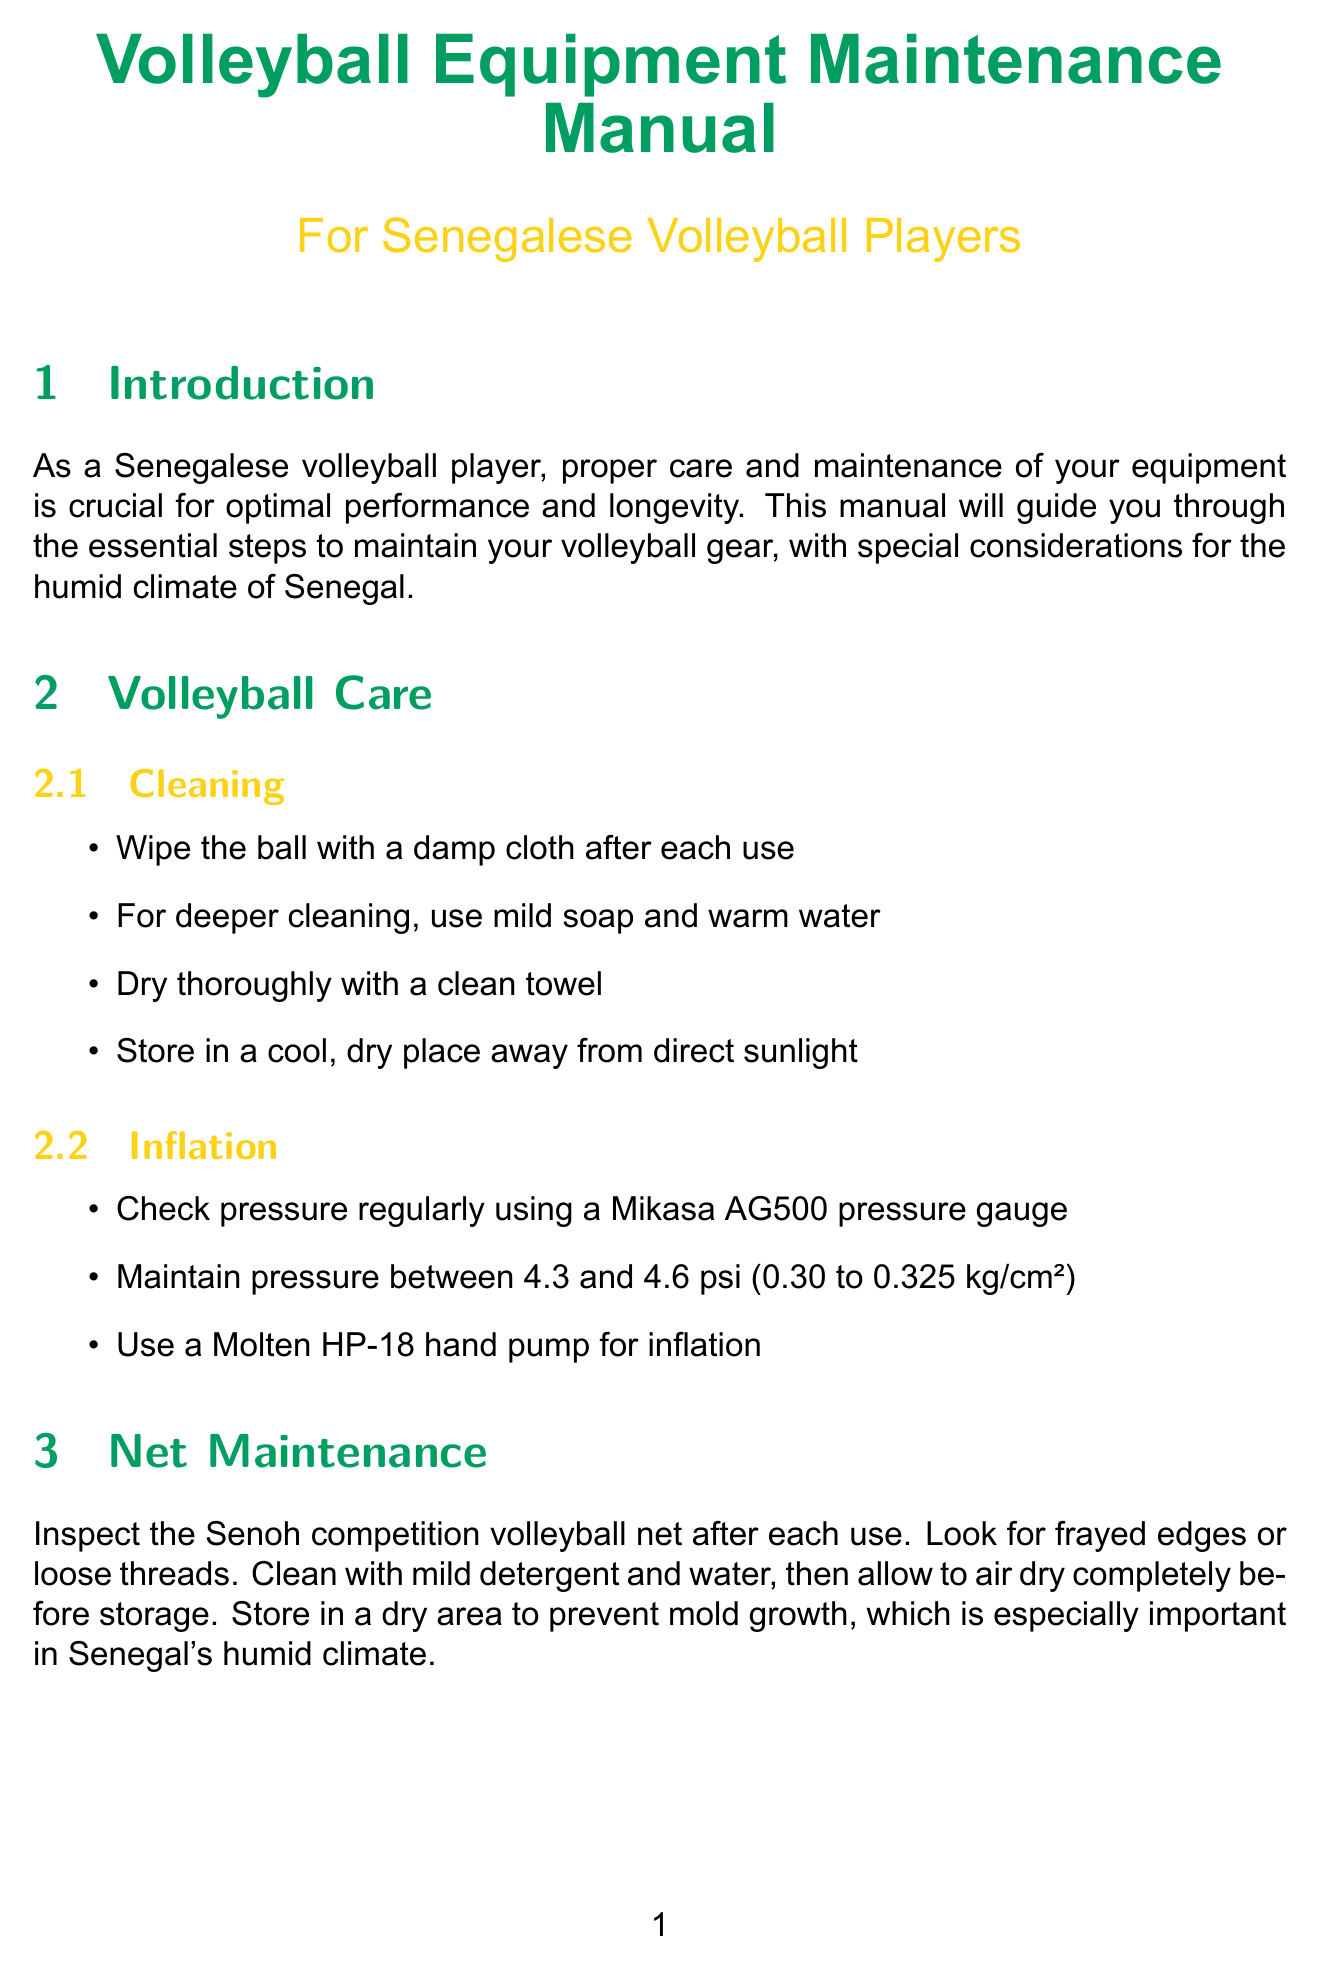What is the proper temperature for air drying shoes? The shoe care section states to air dry at room temperature, away from direct heat sources.
Answer: Room temperature What should you use for cleaning a volleyball net? The net maintenance section recommends using mild detergent and water for cleaning.
Answer: Mild detergent and water How often should you inspect the volleyball standards? The court equipment section suggests regularly inspecting the Jaypro volleyball standards.
Answer: Regularly What is the pressure range for volleyball inflation? The inflation steps specify to maintain pressure between 4.3 and 4.6 psi.
Answer: 4.3 to 4.6 psi What does the uniform care advise against using? The uniform care section advises avoiding fabric softeners as they can affect moisture-wicking properties.
Answer: Fabric softeners How should knee pads be dried before the next use? The knee pad maintenance section states that they should be air dried completely.
Answer: Air dry completely What type of bag is recommended for organizing gear? The equipment bag organization section recommends using a Mikasa VL2000 volleyball bag.
Answer: Mikasa VL2000 volleyball bag What is a suggested storage method for shoes? The shoe care storage section recommends using moisture-absorbing sachets in your shoe bag.
Answer: Moisture-absorbing sachets What cleaning method is suggested for the volleyball? The volleyball care section suggests wiping the ball with a damp cloth after each use.
Answer: Wipe with a damp cloth 